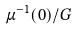Convert formula to latex. <formula><loc_0><loc_0><loc_500><loc_500>\mu ^ { - 1 } ( 0 ) / G</formula> 